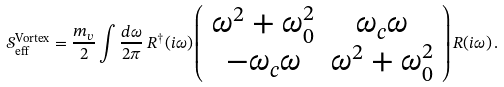<formula> <loc_0><loc_0><loc_500><loc_500>\mathcal { S } _ { \text {eff} } ^ { \text {Vortex} } = \frac { m _ { v } } { 2 } \int \frac { d \omega } { 2 \pi } \, { R } ^ { \dagger } ( i \omega ) \left ( \begin{array} { c c } \omega ^ { 2 } + \omega _ { 0 } ^ { 2 } & \omega _ { c } \omega \\ - \omega _ { c } \omega & \omega ^ { 2 } + \omega _ { 0 } ^ { 2 } \end{array} \right ) { R } ( i \omega ) \, .</formula> 